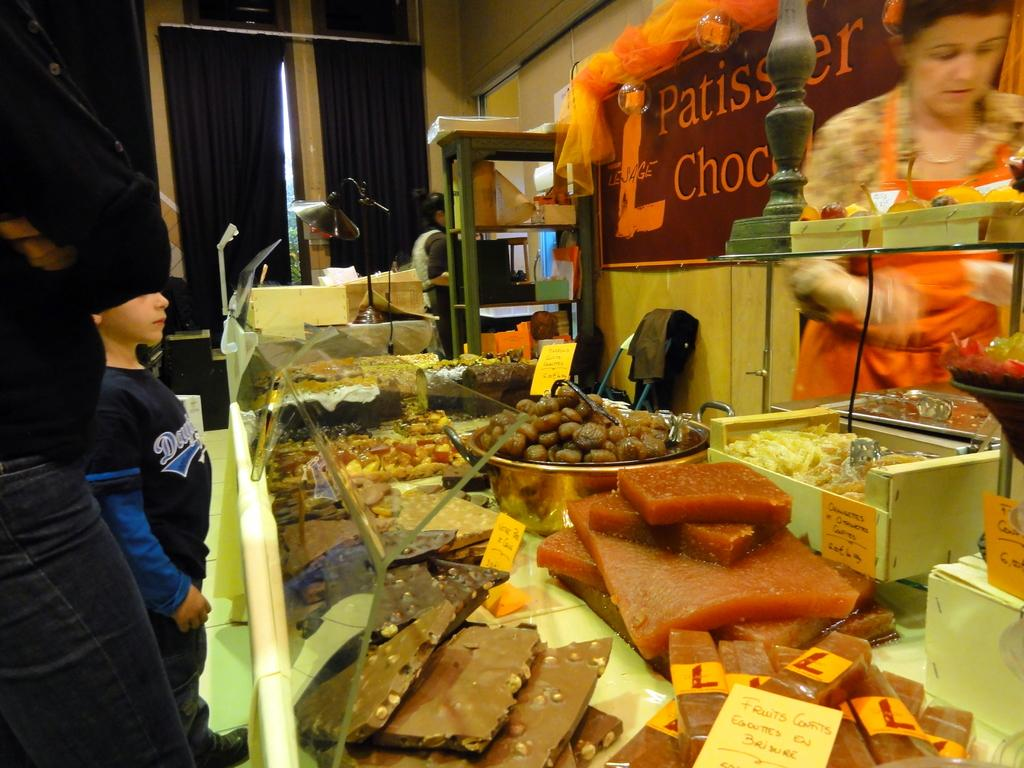<image>
Present a compact description of the photo's key features. Person buying some food at a stand with a sign that has a giant letter "L". 